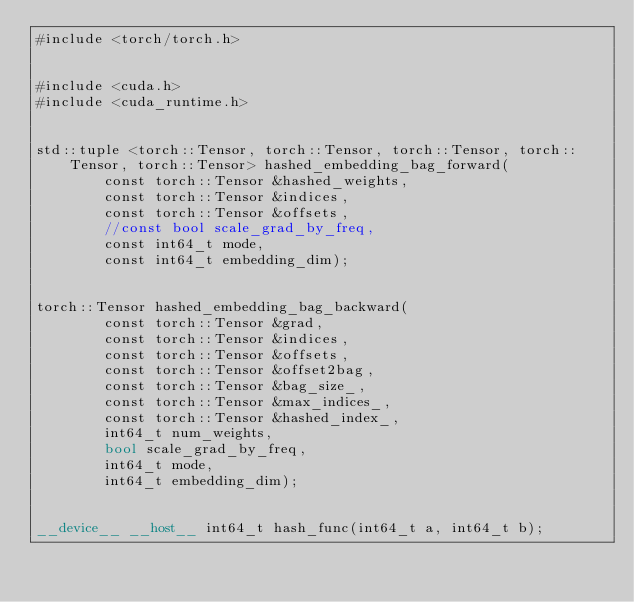<code> <loc_0><loc_0><loc_500><loc_500><_Cuda_>#include <torch/torch.h>


#include <cuda.h>
#include <cuda_runtime.h>


std::tuple <torch::Tensor, torch::Tensor, torch::Tensor, torch::Tensor, torch::Tensor> hashed_embedding_bag_forward(
        const torch::Tensor &hashed_weights,
        const torch::Tensor &indices,
        const torch::Tensor &offsets,
        //const bool scale_grad_by_freq,
        const int64_t mode,
        const int64_t embedding_dim);


torch::Tensor hashed_embedding_bag_backward(
        const torch::Tensor &grad,
        const torch::Tensor &indices,
        const torch::Tensor &offsets,
        const torch::Tensor &offset2bag,
        const torch::Tensor &bag_size_,
        const torch::Tensor &max_indices_,
        const torch::Tensor &hashed_index_,
        int64_t num_weights,
        bool scale_grad_by_freq,
        int64_t mode,
        int64_t embedding_dim);


__device__ __host__ int64_t hash_func(int64_t a, int64_t b);
</code> 